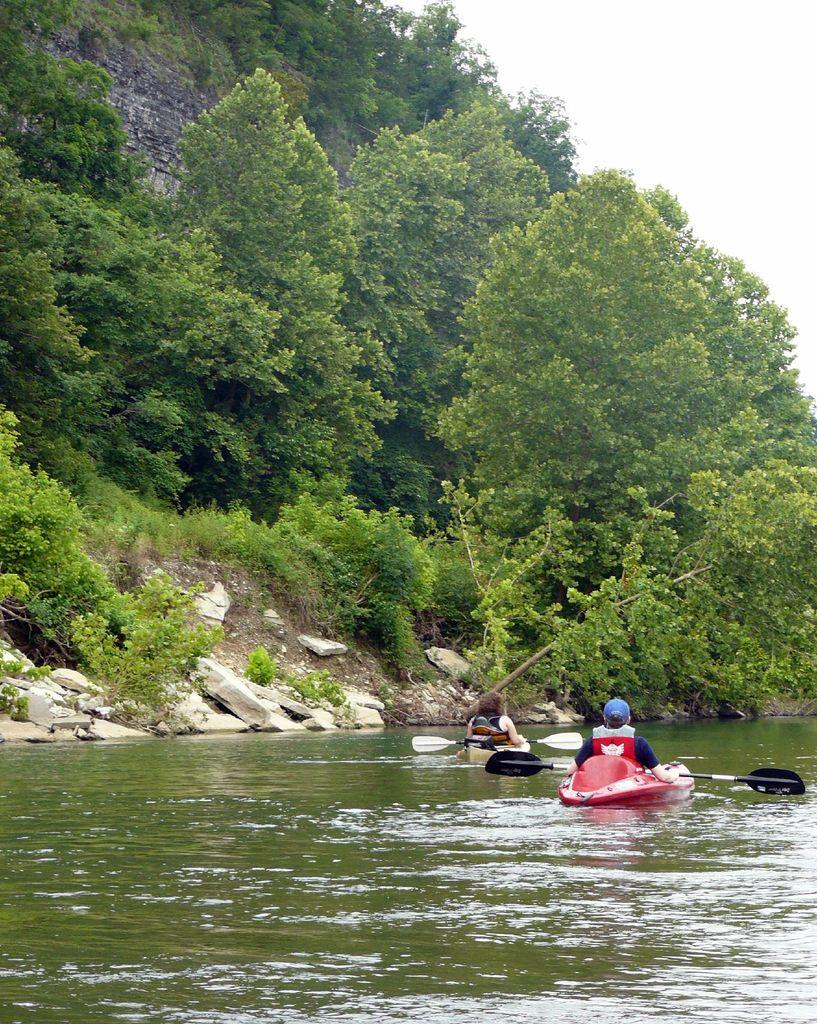What type of natural elements can be seen in the image? There are rocks and trees in the image. What is visible in the sky in the image? The sky is visible in the image. What is on the water in the image? There are boats on the water in the image. What are the persons on the boats doing? The persons are sitting on the boats and holding paddles. Can you tell me how many friends are sitting on the sofa in the image? There is no sofa or friends present in the image. What type of seat can be seen in the image? There is no specific seat visible in the image; the persons are sitting on boats. 